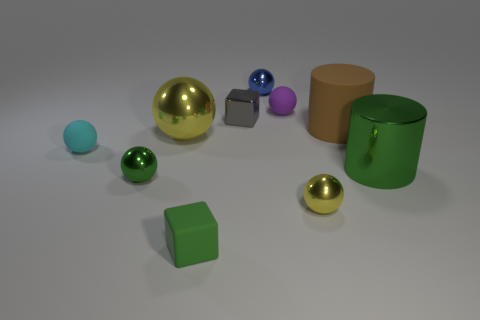Subtract all green balls. How many balls are left? 5 Subtract all purple cylinders. How many yellow spheres are left? 2 Subtract 4 balls. How many balls are left? 2 Subtract all cyan balls. How many balls are left? 5 Subtract all blocks. How many objects are left? 8 Add 8 blue metal things. How many blue metal things are left? 9 Add 9 big blue shiny balls. How many big blue shiny balls exist? 9 Subtract 0 purple blocks. How many objects are left? 10 Subtract all brown cubes. Subtract all yellow cylinders. How many cubes are left? 2 Subtract all blue matte balls. Subtract all brown cylinders. How many objects are left? 9 